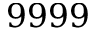<formula> <loc_0><loc_0><loc_500><loc_500>9 9 9 9</formula> 